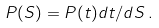<formula> <loc_0><loc_0><loc_500><loc_500>P ( S ) = P ( t ) d t / d S \, .</formula> 